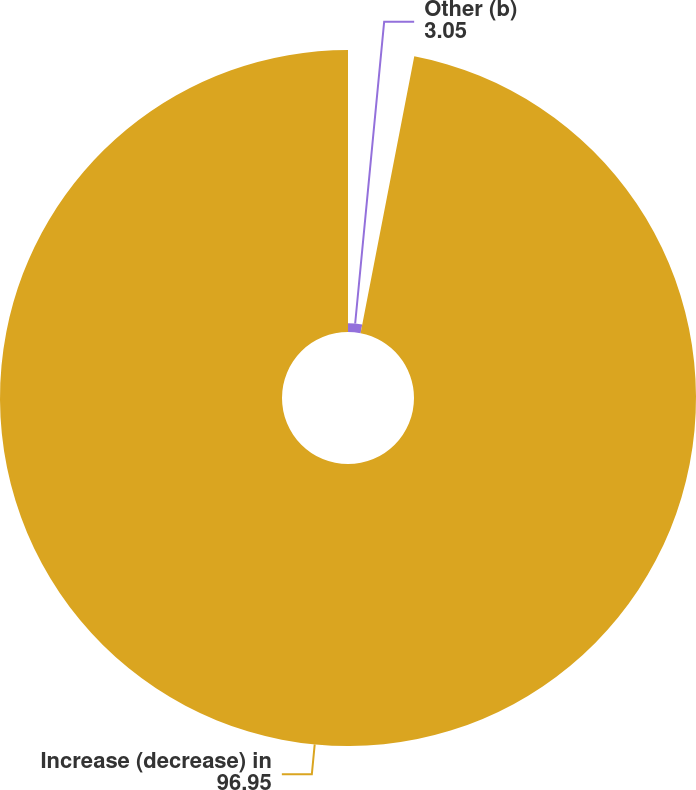Convert chart to OTSL. <chart><loc_0><loc_0><loc_500><loc_500><pie_chart><fcel>Other (b)<fcel>Increase (decrease) in<nl><fcel>3.05%<fcel>96.95%<nl></chart> 